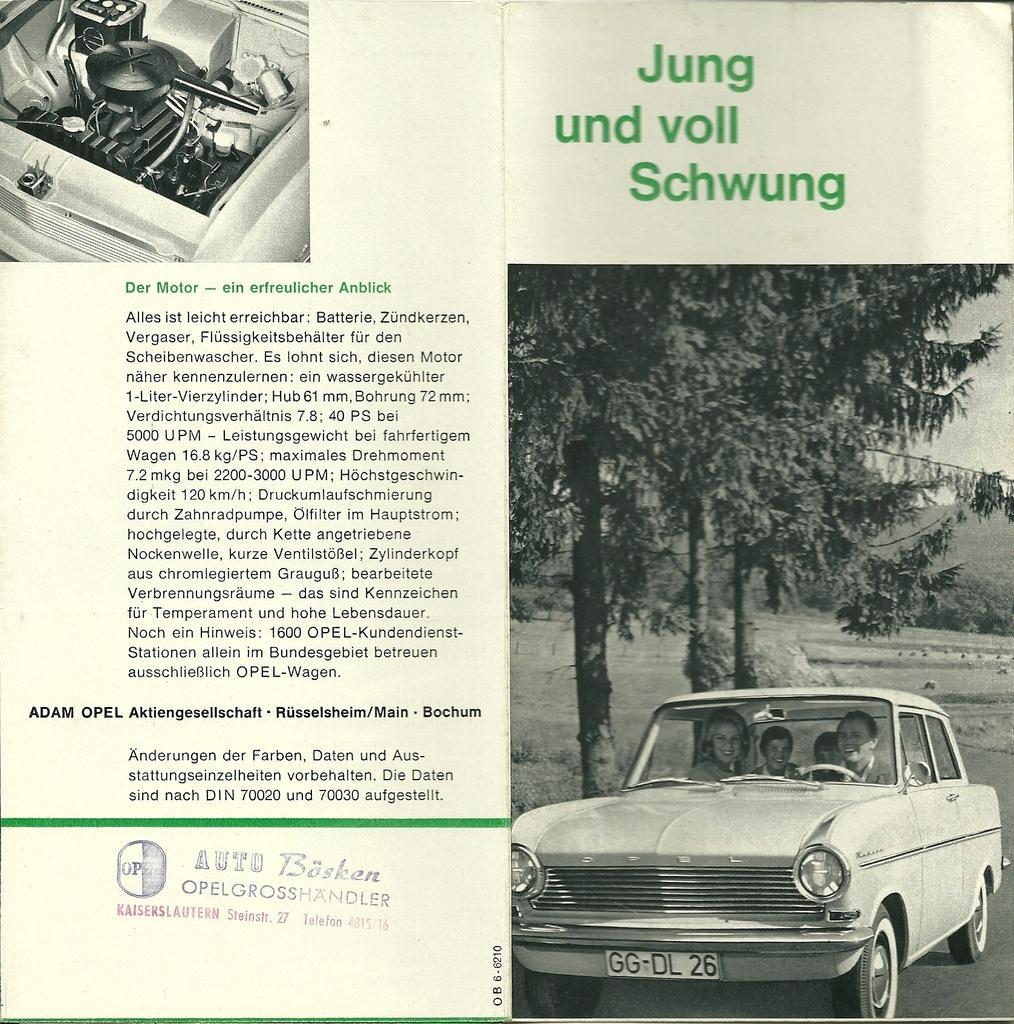Please provide a concise description of this image. In this image we can see an image of a paper. On the right side, we can see some text and image. In the image we can see a car, sky and a group of trees. In the car we can see few persons. On the left side, we can see some text and an image. 